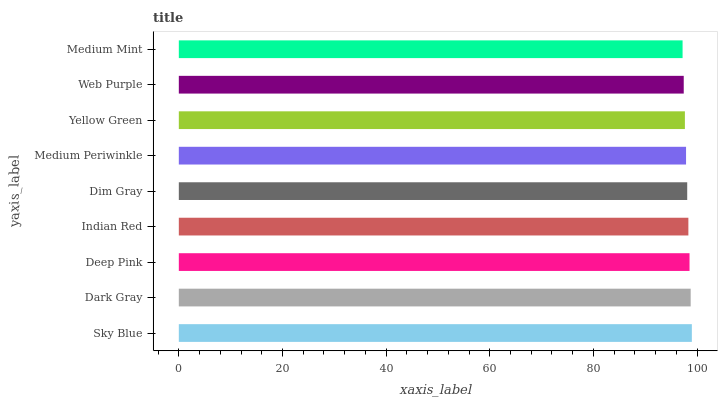Is Medium Mint the minimum?
Answer yes or no. Yes. Is Sky Blue the maximum?
Answer yes or no. Yes. Is Dark Gray the minimum?
Answer yes or no. No. Is Dark Gray the maximum?
Answer yes or no. No. Is Sky Blue greater than Dark Gray?
Answer yes or no. Yes. Is Dark Gray less than Sky Blue?
Answer yes or no. Yes. Is Dark Gray greater than Sky Blue?
Answer yes or no. No. Is Sky Blue less than Dark Gray?
Answer yes or no. No. Is Dim Gray the high median?
Answer yes or no. Yes. Is Dim Gray the low median?
Answer yes or no. Yes. Is Yellow Green the high median?
Answer yes or no. No. Is Medium Periwinkle the low median?
Answer yes or no. No. 